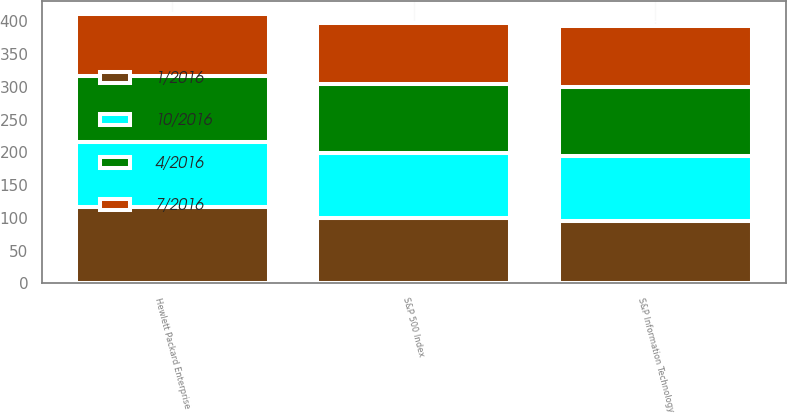Convert chart. <chart><loc_0><loc_0><loc_500><loc_500><stacked_bar_chart><ecel><fcel>Hewlett Packard Enterprise<fcel>S&P 500 Index<fcel>S&P Information Technology<nl><fcel>10/2016<fcel>100<fcel>100<fcel>100<nl><fcel>7/2016<fcel>95.3<fcel>92.71<fcel>92.88<nl><fcel>1/2016<fcel>115.78<fcel>99.25<fcel>94.74<nl><fcel>4/2016<fcel>100<fcel>105.02<fcel>104.96<nl></chart> 